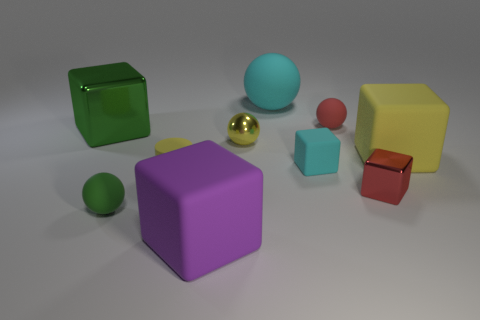Can you describe the textures of the items shown in the image? Certainly! In the image, we see various objects with different textures. The large green and yellow blocks appear to have matte and slightly rough textures, suggesting they might be made of a plastic or coated wood. The balls, particularly the turquoise one and the small golden one, have smoother, shinier textures, indicative of a material like polished plastic or metal. The smaller red block has a solid, opaque surface with a slight sheen. These different textures not only add visual interest but can also tell us about the materials the objects are made of. 